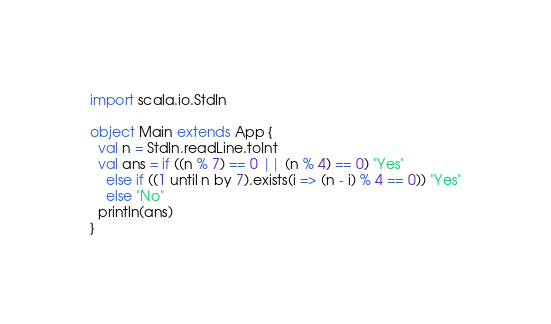<code> <loc_0><loc_0><loc_500><loc_500><_Scala_>import scala.io.StdIn

object Main extends App {
  val n = StdIn.readLine.toInt
  val ans = if ((n % 7) == 0 || (n % 4) == 0) "Yes"
    else if ((1 until n by 7).exists(i => (n - i) % 4 == 0)) "Yes"
    else "No"
  println(ans)
}</code> 